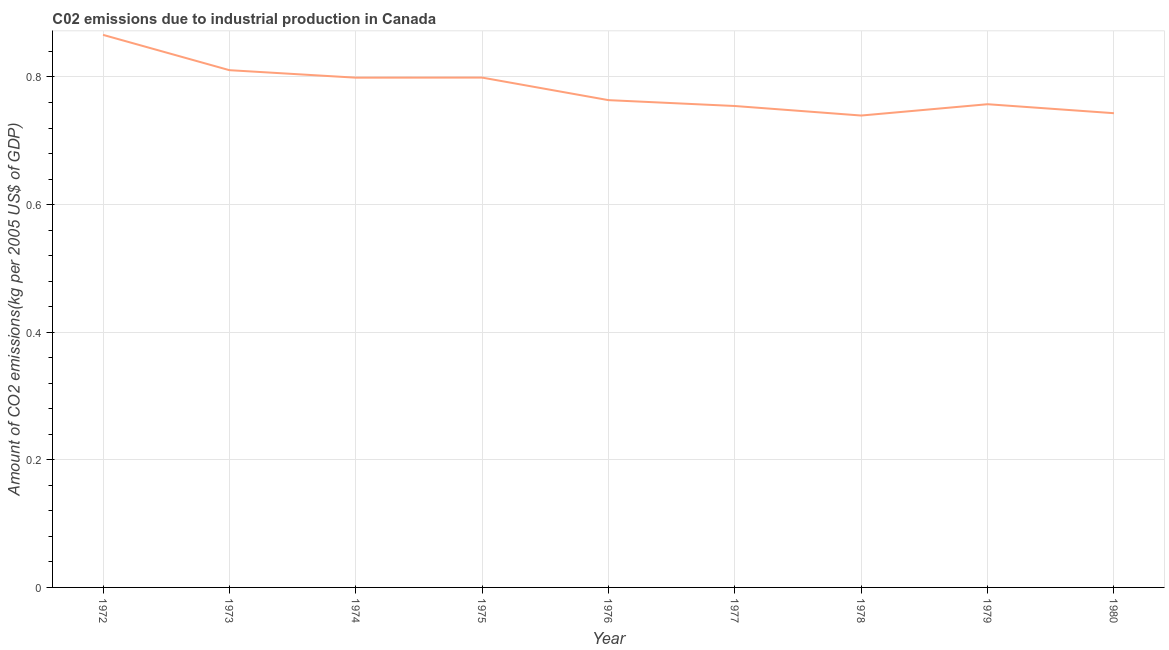What is the amount of co2 emissions in 1975?
Provide a succinct answer. 0.8. Across all years, what is the maximum amount of co2 emissions?
Ensure brevity in your answer.  0.87. Across all years, what is the minimum amount of co2 emissions?
Provide a short and direct response. 0.74. In which year was the amount of co2 emissions minimum?
Provide a succinct answer. 1978. What is the sum of the amount of co2 emissions?
Offer a terse response. 7.03. What is the difference between the amount of co2 emissions in 1973 and 1975?
Offer a very short reply. 0.01. What is the average amount of co2 emissions per year?
Ensure brevity in your answer.  0.78. What is the median amount of co2 emissions?
Your response must be concise. 0.76. In how many years, is the amount of co2 emissions greater than 0.16 kg per 2005 US$ of GDP?
Give a very brief answer. 9. What is the ratio of the amount of co2 emissions in 1978 to that in 1979?
Your answer should be compact. 0.98. Is the difference between the amount of co2 emissions in 1976 and 1980 greater than the difference between any two years?
Give a very brief answer. No. What is the difference between the highest and the second highest amount of co2 emissions?
Your response must be concise. 0.06. Is the sum of the amount of co2 emissions in 1974 and 1980 greater than the maximum amount of co2 emissions across all years?
Give a very brief answer. Yes. What is the difference between the highest and the lowest amount of co2 emissions?
Ensure brevity in your answer.  0.13. In how many years, is the amount of co2 emissions greater than the average amount of co2 emissions taken over all years?
Provide a succinct answer. 4. Does the amount of co2 emissions monotonically increase over the years?
Your answer should be very brief. No. How many lines are there?
Make the answer very short. 1. Does the graph contain any zero values?
Ensure brevity in your answer.  No. Does the graph contain grids?
Give a very brief answer. Yes. What is the title of the graph?
Your answer should be very brief. C02 emissions due to industrial production in Canada. What is the label or title of the X-axis?
Your answer should be very brief. Year. What is the label or title of the Y-axis?
Ensure brevity in your answer.  Amount of CO2 emissions(kg per 2005 US$ of GDP). What is the Amount of CO2 emissions(kg per 2005 US$ of GDP) of 1972?
Give a very brief answer. 0.87. What is the Amount of CO2 emissions(kg per 2005 US$ of GDP) of 1973?
Your response must be concise. 0.81. What is the Amount of CO2 emissions(kg per 2005 US$ of GDP) in 1974?
Provide a short and direct response. 0.8. What is the Amount of CO2 emissions(kg per 2005 US$ of GDP) of 1975?
Offer a terse response. 0.8. What is the Amount of CO2 emissions(kg per 2005 US$ of GDP) in 1976?
Your response must be concise. 0.76. What is the Amount of CO2 emissions(kg per 2005 US$ of GDP) of 1977?
Keep it short and to the point. 0.75. What is the Amount of CO2 emissions(kg per 2005 US$ of GDP) of 1978?
Make the answer very short. 0.74. What is the Amount of CO2 emissions(kg per 2005 US$ of GDP) of 1979?
Provide a succinct answer. 0.76. What is the Amount of CO2 emissions(kg per 2005 US$ of GDP) in 1980?
Your response must be concise. 0.74. What is the difference between the Amount of CO2 emissions(kg per 2005 US$ of GDP) in 1972 and 1973?
Provide a short and direct response. 0.06. What is the difference between the Amount of CO2 emissions(kg per 2005 US$ of GDP) in 1972 and 1974?
Your answer should be very brief. 0.07. What is the difference between the Amount of CO2 emissions(kg per 2005 US$ of GDP) in 1972 and 1975?
Your response must be concise. 0.07. What is the difference between the Amount of CO2 emissions(kg per 2005 US$ of GDP) in 1972 and 1976?
Offer a very short reply. 0.1. What is the difference between the Amount of CO2 emissions(kg per 2005 US$ of GDP) in 1972 and 1977?
Offer a terse response. 0.11. What is the difference between the Amount of CO2 emissions(kg per 2005 US$ of GDP) in 1972 and 1978?
Offer a very short reply. 0.13. What is the difference between the Amount of CO2 emissions(kg per 2005 US$ of GDP) in 1972 and 1979?
Offer a terse response. 0.11. What is the difference between the Amount of CO2 emissions(kg per 2005 US$ of GDP) in 1972 and 1980?
Provide a succinct answer. 0.12. What is the difference between the Amount of CO2 emissions(kg per 2005 US$ of GDP) in 1973 and 1974?
Your answer should be very brief. 0.01. What is the difference between the Amount of CO2 emissions(kg per 2005 US$ of GDP) in 1973 and 1975?
Make the answer very short. 0.01. What is the difference between the Amount of CO2 emissions(kg per 2005 US$ of GDP) in 1973 and 1976?
Provide a succinct answer. 0.05. What is the difference between the Amount of CO2 emissions(kg per 2005 US$ of GDP) in 1973 and 1977?
Ensure brevity in your answer.  0.06. What is the difference between the Amount of CO2 emissions(kg per 2005 US$ of GDP) in 1973 and 1978?
Make the answer very short. 0.07. What is the difference between the Amount of CO2 emissions(kg per 2005 US$ of GDP) in 1973 and 1979?
Your answer should be very brief. 0.05. What is the difference between the Amount of CO2 emissions(kg per 2005 US$ of GDP) in 1973 and 1980?
Offer a very short reply. 0.07. What is the difference between the Amount of CO2 emissions(kg per 2005 US$ of GDP) in 1974 and 1975?
Your answer should be very brief. -0. What is the difference between the Amount of CO2 emissions(kg per 2005 US$ of GDP) in 1974 and 1976?
Your answer should be very brief. 0.04. What is the difference between the Amount of CO2 emissions(kg per 2005 US$ of GDP) in 1974 and 1977?
Give a very brief answer. 0.04. What is the difference between the Amount of CO2 emissions(kg per 2005 US$ of GDP) in 1974 and 1978?
Your answer should be very brief. 0.06. What is the difference between the Amount of CO2 emissions(kg per 2005 US$ of GDP) in 1974 and 1979?
Provide a short and direct response. 0.04. What is the difference between the Amount of CO2 emissions(kg per 2005 US$ of GDP) in 1974 and 1980?
Keep it short and to the point. 0.06. What is the difference between the Amount of CO2 emissions(kg per 2005 US$ of GDP) in 1975 and 1976?
Give a very brief answer. 0.04. What is the difference between the Amount of CO2 emissions(kg per 2005 US$ of GDP) in 1975 and 1977?
Your answer should be very brief. 0.04. What is the difference between the Amount of CO2 emissions(kg per 2005 US$ of GDP) in 1975 and 1978?
Offer a very short reply. 0.06. What is the difference between the Amount of CO2 emissions(kg per 2005 US$ of GDP) in 1975 and 1979?
Provide a succinct answer. 0.04. What is the difference between the Amount of CO2 emissions(kg per 2005 US$ of GDP) in 1975 and 1980?
Provide a short and direct response. 0.06. What is the difference between the Amount of CO2 emissions(kg per 2005 US$ of GDP) in 1976 and 1977?
Offer a terse response. 0.01. What is the difference between the Amount of CO2 emissions(kg per 2005 US$ of GDP) in 1976 and 1978?
Your answer should be very brief. 0.02. What is the difference between the Amount of CO2 emissions(kg per 2005 US$ of GDP) in 1976 and 1979?
Offer a terse response. 0.01. What is the difference between the Amount of CO2 emissions(kg per 2005 US$ of GDP) in 1976 and 1980?
Provide a short and direct response. 0.02. What is the difference between the Amount of CO2 emissions(kg per 2005 US$ of GDP) in 1977 and 1978?
Offer a very short reply. 0.01. What is the difference between the Amount of CO2 emissions(kg per 2005 US$ of GDP) in 1977 and 1979?
Provide a short and direct response. -0. What is the difference between the Amount of CO2 emissions(kg per 2005 US$ of GDP) in 1977 and 1980?
Ensure brevity in your answer.  0.01. What is the difference between the Amount of CO2 emissions(kg per 2005 US$ of GDP) in 1978 and 1979?
Keep it short and to the point. -0.02. What is the difference between the Amount of CO2 emissions(kg per 2005 US$ of GDP) in 1978 and 1980?
Your answer should be very brief. -0. What is the difference between the Amount of CO2 emissions(kg per 2005 US$ of GDP) in 1979 and 1980?
Your response must be concise. 0.01. What is the ratio of the Amount of CO2 emissions(kg per 2005 US$ of GDP) in 1972 to that in 1973?
Provide a succinct answer. 1.07. What is the ratio of the Amount of CO2 emissions(kg per 2005 US$ of GDP) in 1972 to that in 1974?
Your answer should be compact. 1.08. What is the ratio of the Amount of CO2 emissions(kg per 2005 US$ of GDP) in 1972 to that in 1975?
Your answer should be very brief. 1.08. What is the ratio of the Amount of CO2 emissions(kg per 2005 US$ of GDP) in 1972 to that in 1976?
Give a very brief answer. 1.13. What is the ratio of the Amount of CO2 emissions(kg per 2005 US$ of GDP) in 1972 to that in 1977?
Your response must be concise. 1.15. What is the ratio of the Amount of CO2 emissions(kg per 2005 US$ of GDP) in 1972 to that in 1978?
Make the answer very short. 1.17. What is the ratio of the Amount of CO2 emissions(kg per 2005 US$ of GDP) in 1972 to that in 1979?
Keep it short and to the point. 1.14. What is the ratio of the Amount of CO2 emissions(kg per 2005 US$ of GDP) in 1972 to that in 1980?
Ensure brevity in your answer.  1.17. What is the ratio of the Amount of CO2 emissions(kg per 2005 US$ of GDP) in 1973 to that in 1974?
Offer a terse response. 1.01. What is the ratio of the Amount of CO2 emissions(kg per 2005 US$ of GDP) in 1973 to that in 1975?
Ensure brevity in your answer.  1.01. What is the ratio of the Amount of CO2 emissions(kg per 2005 US$ of GDP) in 1973 to that in 1976?
Your response must be concise. 1.06. What is the ratio of the Amount of CO2 emissions(kg per 2005 US$ of GDP) in 1973 to that in 1977?
Give a very brief answer. 1.07. What is the ratio of the Amount of CO2 emissions(kg per 2005 US$ of GDP) in 1973 to that in 1978?
Your answer should be very brief. 1.1. What is the ratio of the Amount of CO2 emissions(kg per 2005 US$ of GDP) in 1973 to that in 1979?
Your response must be concise. 1.07. What is the ratio of the Amount of CO2 emissions(kg per 2005 US$ of GDP) in 1973 to that in 1980?
Your response must be concise. 1.09. What is the ratio of the Amount of CO2 emissions(kg per 2005 US$ of GDP) in 1974 to that in 1975?
Provide a short and direct response. 1. What is the ratio of the Amount of CO2 emissions(kg per 2005 US$ of GDP) in 1974 to that in 1976?
Keep it short and to the point. 1.05. What is the ratio of the Amount of CO2 emissions(kg per 2005 US$ of GDP) in 1974 to that in 1977?
Make the answer very short. 1.06. What is the ratio of the Amount of CO2 emissions(kg per 2005 US$ of GDP) in 1974 to that in 1978?
Offer a very short reply. 1.08. What is the ratio of the Amount of CO2 emissions(kg per 2005 US$ of GDP) in 1974 to that in 1979?
Give a very brief answer. 1.05. What is the ratio of the Amount of CO2 emissions(kg per 2005 US$ of GDP) in 1974 to that in 1980?
Offer a terse response. 1.07. What is the ratio of the Amount of CO2 emissions(kg per 2005 US$ of GDP) in 1975 to that in 1976?
Provide a succinct answer. 1.05. What is the ratio of the Amount of CO2 emissions(kg per 2005 US$ of GDP) in 1975 to that in 1977?
Make the answer very short. 1.06. What is the ratio of the Amount of CO2 emissions(kg per 2005 US$ of GDP) in 1975 to that in 1978?
Make the answer very short. 1.08. What is the ratio of the Amount of CO2 emissions(kg per 2005 US$ of GDP) in 1975 to that in 1979?
Give a very brief answer. 1.05. What is the ratio of the Amount of CO2 emissions(kg per 2005 US$ of GDP) in 1975 to that in 1980?
Your answer should be very brief. 1.07. What is the ratio of the Amount of CO2 emissions(kg per 2005 US$ of GDP) in 1976 to that in 1977?
Give a very brief answer. 1.01. What is the ratio of the Amount of CO2 emissions(kg per 2005 US$ of GDP) in 1976 to that in 1978?
Your answer should be compact. 1.03. What is the ratio of the Amount of CO2 emissions(kg per 2005 US$ of GDP) in 1976 to that in 1980?
Give a very brief answer. 1.03. What is the ratio of the Amount of CO2 emissions(kg per 2005 US$ of GDP) in 1977 to that in 1980?
Provide a short and direct response. 1.01. What is the ratio of the Amount of CO2 emissions(kg per 2005 US$ of GDP) in 1978 to that in 1980?
Offer a very short reply. 0.99. What is the ratio of the Amount of CO2 emissions(kg per 2005 US$ of GDP) in 1979 to that in 1980?
Provide a short and direct response. 1.02. 